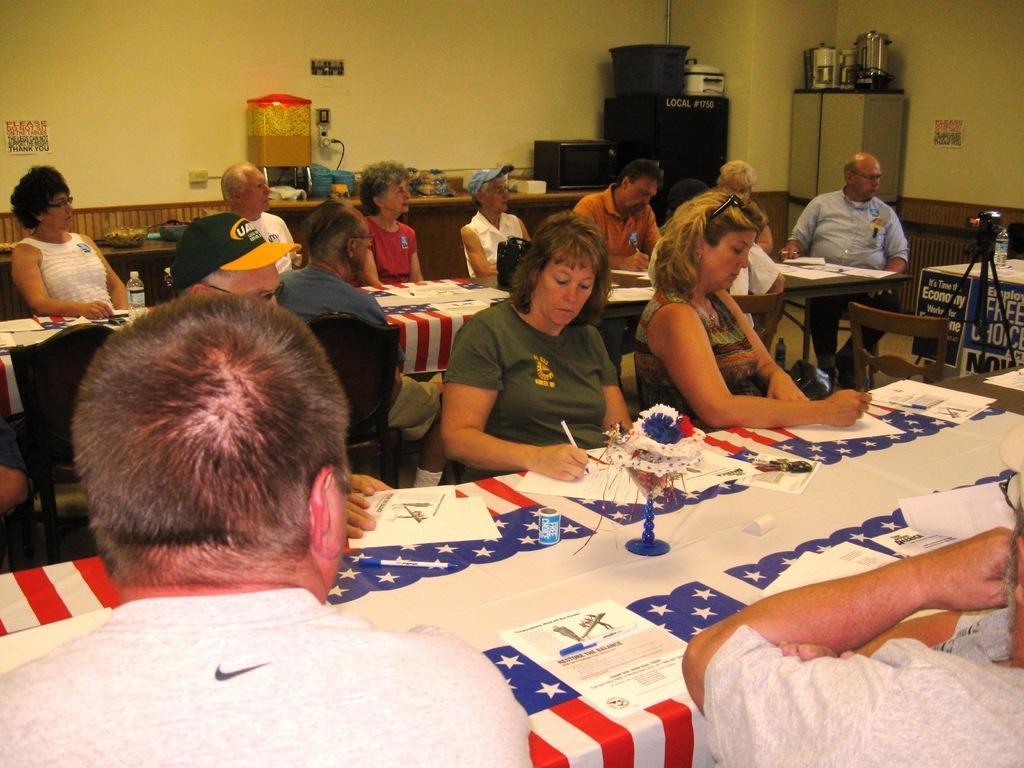Describe this image in one or two sentences. In this picture I can see there are a group of people sitting around the table and few of them are looking at the right. There are having pens and few papers on the table and there are few objects in the backdrop. 